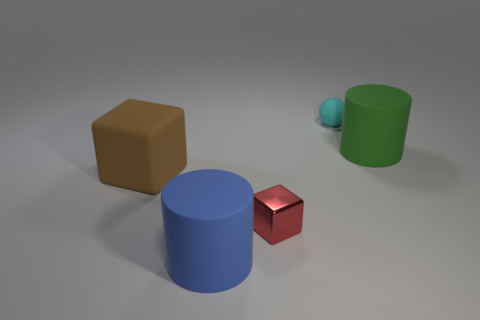The tiny ball that is made of the same material as the big brown cube is what color?
Provide a short and direct response. Cyan. Are the small ball that is on the right side of the rubber block and the tiny red thing that is to the left of the tiny cyan sphere made of the same material?
Provide a succinct answer. No. Are there any green rubber objects of the same size as the cyan matte ball?
Ensure brevity in your answer.  No. There is a cylinder that is in front of the tiny object that is in front of the tiny sphere; how big is it?
Make the answer very short. Large. How many tiny rubber spheres have the same color as the big rubber block?
Make the answer very short. 0. What shape is the matte thing behind the large rubber cylinder that is behind the brown block?
Your answer should be very brief. Sphere. How many small red things are the same material as the blue cylinder?
Provide a succinct answer. 0. There is a large object that is behind the large matte block; what is it made of?
Offer a terse response. Rubber. What shape is the thing that is on the left side of the big blue object to the left of the block in front of the big block?
Your answer should be compact. Cube. Is the number of big green matte cylinders in front of the red shiny cube less than the number of tiny objects in front of the small cyan object?
Provide a succinct answer. Yes. 